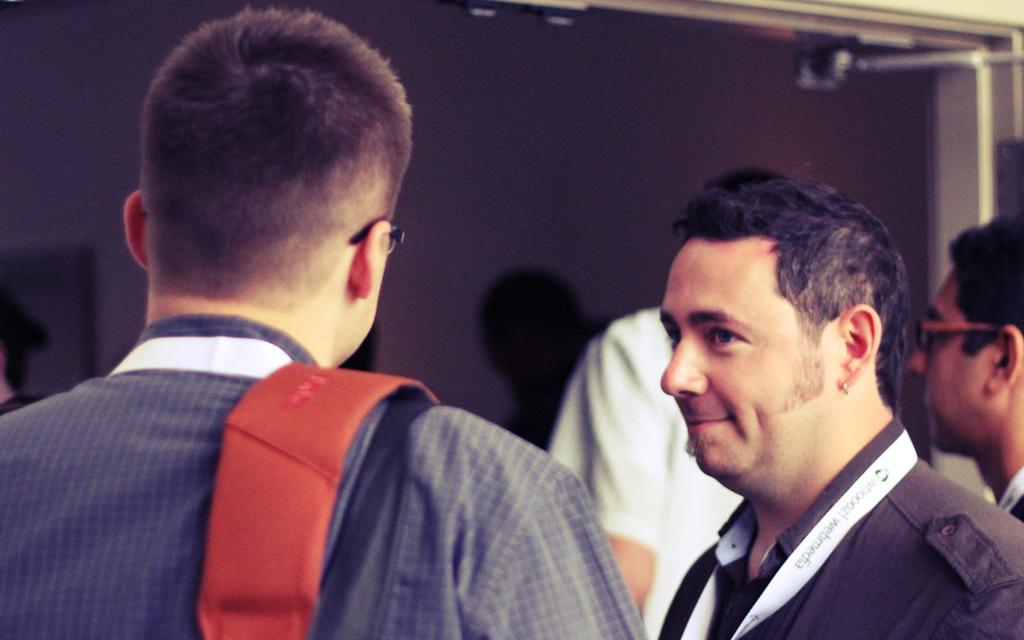Who or what can be seen in the image? There are people in the image. Where are the people located in the image? The people are standing on a path. What type of mark is visible on the path in the image? There is no mention of a mark on the path in the provided facts, so it cannot be determined from the image. 